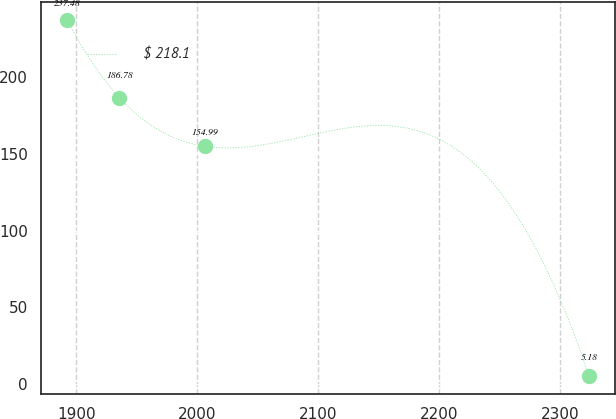Convert chart. <chart><loc_0><loc_0><loc_500><loc_500><line_chart><ecel><fcel>$ 218.1<nl><fcel>1892.53<fcel>237.48<nl><fcel>1935.69<fcel>186.78<nl><fcel>2006.74<fcel>154.99<nl><fcel>2324.16<fcel>5.18<nl></chart> 